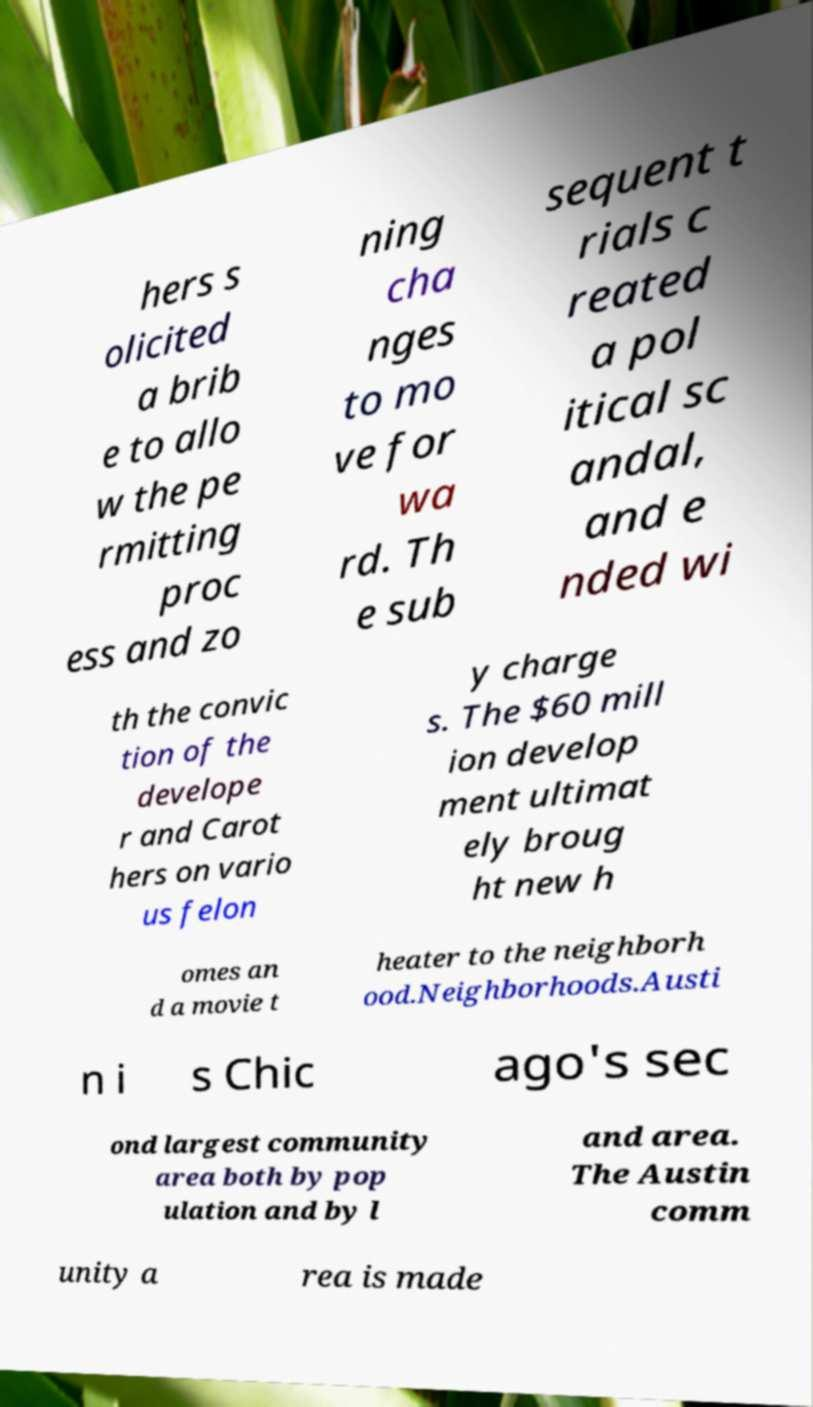Please read and relay the text visible in this image. What does it say? hers s olicited a brib e to allo w the pe rmitting proc ess and zo ning cha nges to mo ve for wa rd. Th e sub sequent t rials c reated a pol itical sc andal, and e nded wi th the convic tion of the develope r and Carot hers on vario us felon y charge s. The $60 mill ion develop ment ultimat ely broug ht new h omes an d a movie t heater to the neighborh ood.Neighborhoods.Austi n i s Chic ago's sec ond largest community area both by pop ulation and by l and area. The Austin comm unity a rea is made 